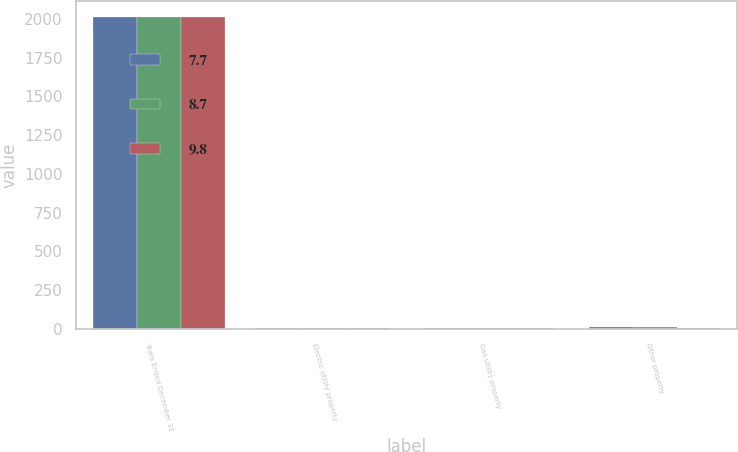<chart> <loc_0><loc_0><loc_500><loc_500><stacked_bar_chart><ecel><fcel>Years Ended December 31<fcel>Electric utility property<fcel>Gas utility property<fcel>Other property<nl><fcel>7.7<fcel>2016<fcel>3.9<fcel>2.9<fcel>9.8<nl><fcel>8.7<fcel>2015<fcel>3.5<fcel>2.8<fcel>8.7<nl><fcel>9.8<fcel>2014<fcel>3.5<fcel>2.8<fcel>7.7<nl></chart> 